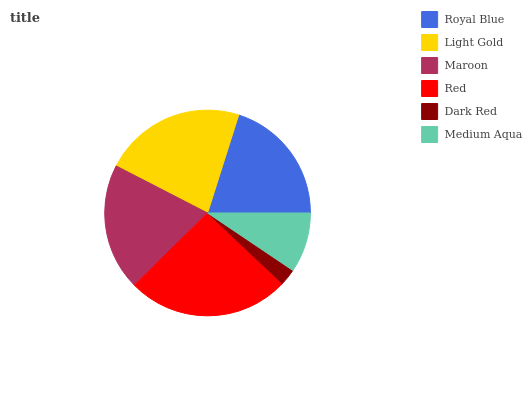Is Dark Red the minimum?
Answer yes or no. Yes. Is Red the maximum?
Answer yes or no. Yes. Is Light Gold the minimum?
Answer yes or no. No. Is Light Gold the maximum?
Answer yes or no. No. Is Light Gold greater than Royal Blue?
Answer yes or no. Yes. Is Royal Blue less than Light Gold?
Answer yes or no. Yes. Is Royal Blue greater than Light Gold?
Answer yes or no. No. Is Light Gold less than Royal Blue?
Answer yes or no. No. Is Royal Blue the high median?
Answer yes or no. Yes. Is Maroon the low median?
Answer yes or no. Yes. Is Medium Aqua the high median?
Answer yes or no. No. Is Medium Aqua the low median?
Answer yes or no. No. 